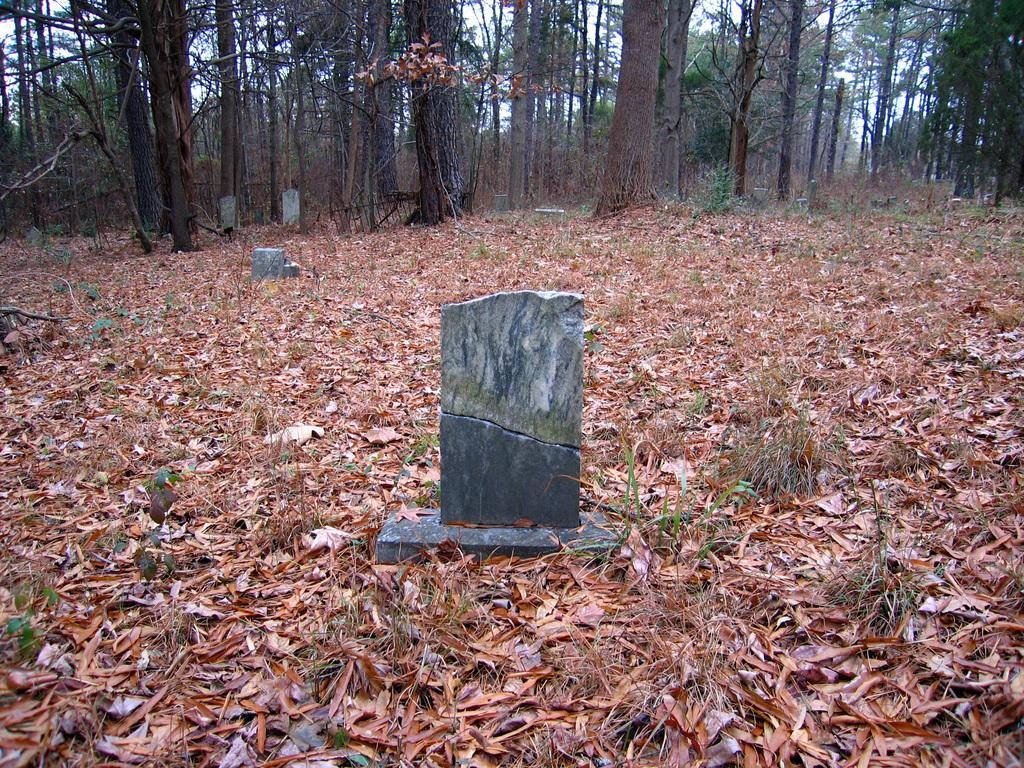Where was the picture taken? The picture was clicked outside. What is the main subject in the center of the image? There are stones in the center of the image. What can be seen on the ground in the image? Dry leaves are lying on the ground. What is visible in the background of the image? There is a sky and trees visible in the background. Are there any plants present in the background? Yes, some plants are present in the background. What color is the shirt worn by the person jumping in the image? There is no person wearing a shirt or jumping in the image; it features stones, dry leaves, and a background with trees and plants. 